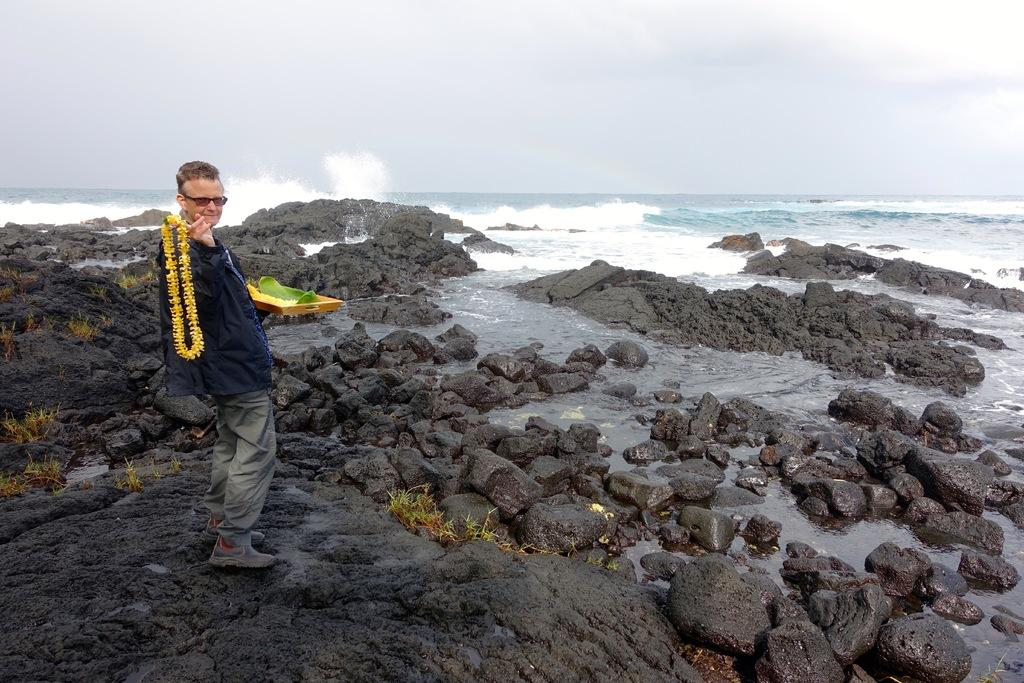What is the man in the image doing? The man is standing on the land on the left side of the image. What is in front of the man? There are rocks in front of the man. What can be seen in the background of the image? There is an ocean and the sky visible in the background of the image. What type of wound can be seen on the man's hand in the image? There is no wound visible on the man's hand in the image. Is the man wearing a tramp or a glove in the image? The man is not wearing a tramp or a glove in the image; he is simply standing on the land with his hands at his sides. 